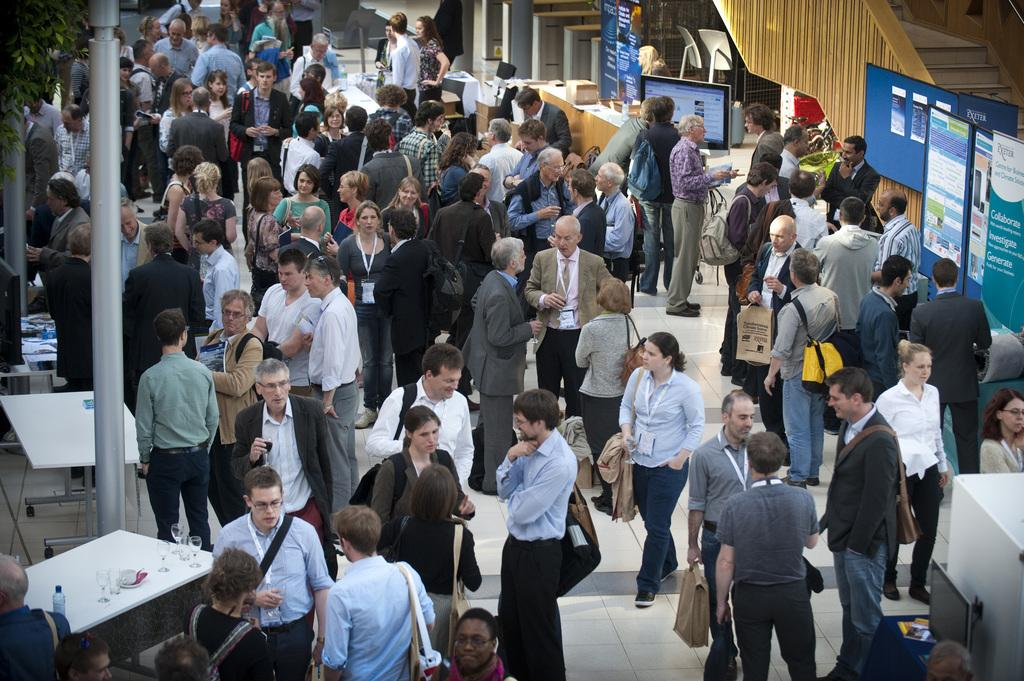How many people are present in the image? There are many people in the image. What is the position of the people in the image? The people are standing on the floor. Can you describe the setting of the image? The setting appears to be a business exhibition or a meeting hall. What type of linen is being used to make the jeans in the image? There are no jeans or linen present in the image; it features a group of people standing in a business exhibition or meeting hall. 